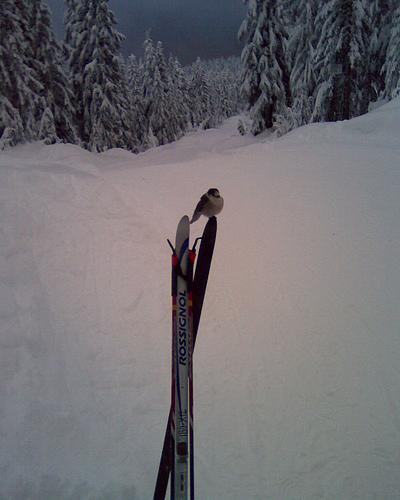Does the bird want to ski?
Answer briefly. No. What are the words on the ski?
Quick response, please. Rossignol. Are the tree covered with snow?
Answer briefly. Yes. 